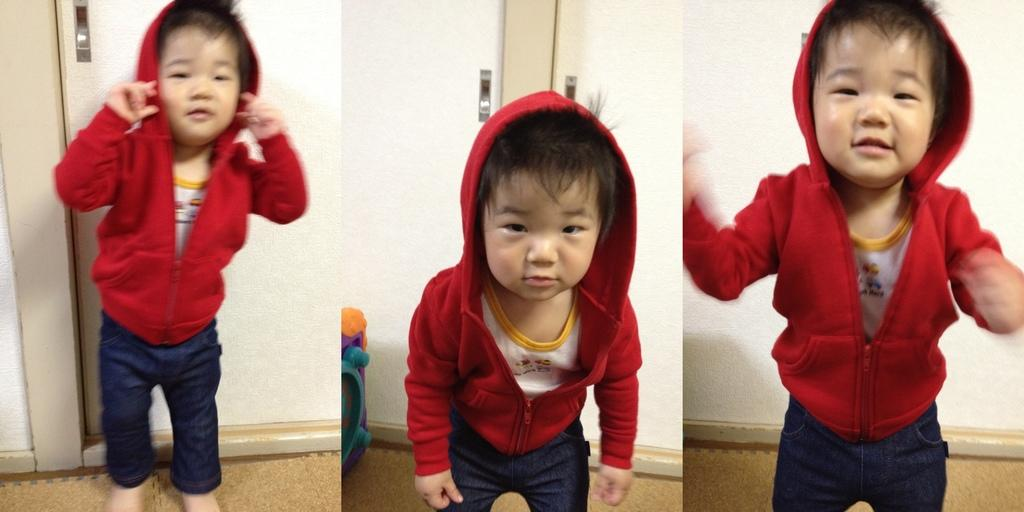What is the main subject of the collage in the image? There is a collage of three images, and the main subject in the middle image is a kid. What can be seen behind the kid in the collage? There is a door visible behind the kid in the collage. What is the kid wearing in the collage? The kid is wearing a red color sweater in the collage. What type of pump can be seen in the image? There is no pump present in the image; it features a collage of three images with a kid in the middle. How much powder is visible in the image? There is no powder visible in the image; it features a collage of three images with a kid in the middle. 